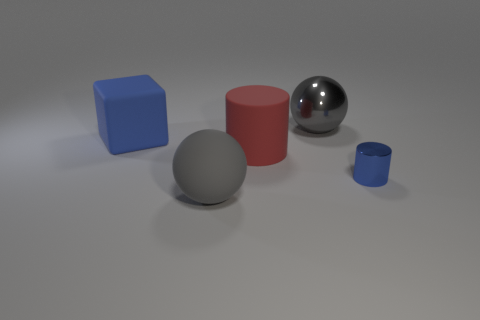Add 5 yellow matte cubes. How many objects exist? 10 Subtract all spheres. How many objects are left? 3 Add 4 large blocks. How many large blocks are left? 5 Add 2 big objects. How many big objects exist? 6 Subtract 1 blue blocks. How many objects are left? 4 Subtract all large red things. Subtract all gray things. How many objects are left? 2 